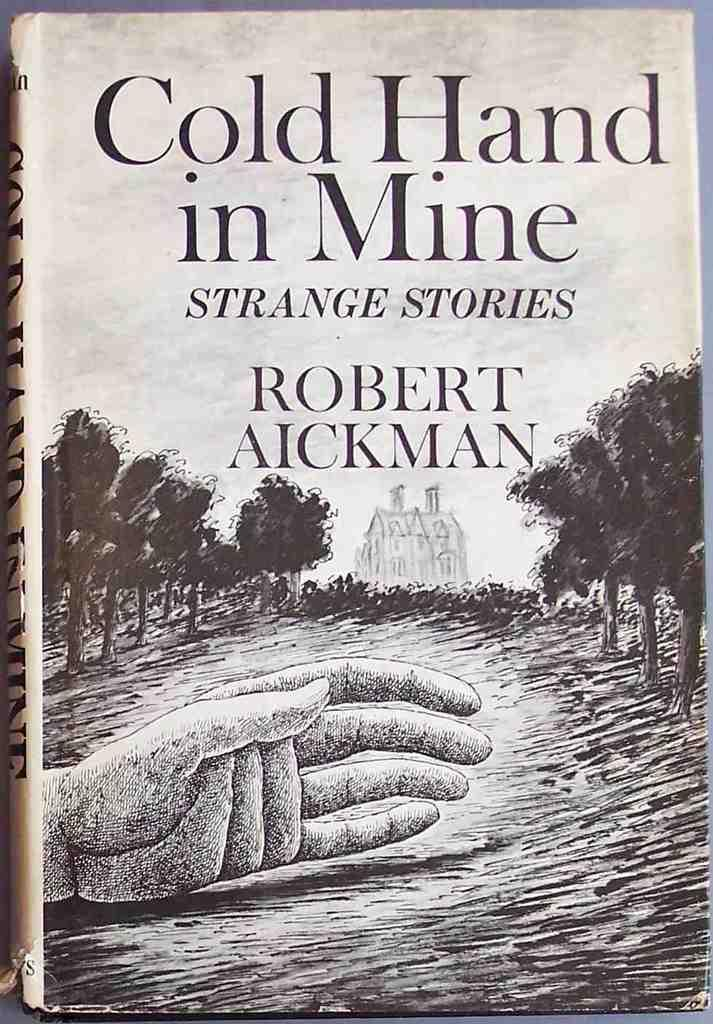<image>
Write a terse but informative summary of the picture. The book is called Cold Hand in Mine and appears to be about strange stories. 